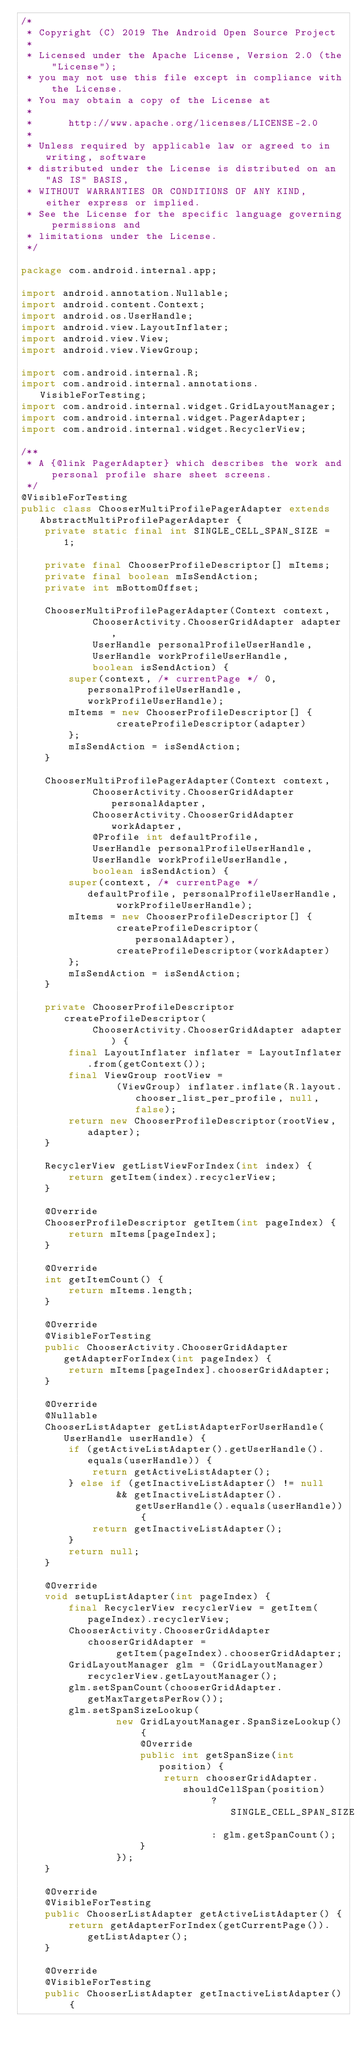Convert code to text. <code><loc_0><loc_0><loc_500><loc_500><_Java_>/*
 * Copyright (C) 2019 The Android Open Source Project
 *
 * Licensed under the Apache License, Version 2.0 (the "License");
 * you may not use this file except in compliance with the License.
 * You may obtain a copy of the License at
 *
 *      http://www.apache.org/licenses/LICENSE-2.0
 *
 * Unless required by applicable law or agreed to in writing, software
 * distributed under the License is distributed on an "AS IS" BASIS,
 * WITHOUT WARRANTIES OR CONDITIONS OF ANY KIND, either express or implied.
 * See the License for the specific language governing permissions and
 * limitations under the License.
 */

package com.android.internal.app;

import android.annotation.Nullable;
import android.content.Context;
import android.os.UserHandle;
import android.view.LayoutInflater;
import android.view.View;
import android.view.ViewGroup;

import com.android.internal.R;
import com.android.internal.annotations.VisibleForTesting;
import com.android.internal.widget.GridLayoutManager;
import com.android.internal.widget.PagerAdapter;
import com.android.internal.widget.RecyclerView;

/**
 * A {@link PagerAdapter} which describes the work and personal profile share sheet screens.
 */
@VisibleForTesting
public class ChooserMultiProfilePagerAdapter extends AbstractMultiProfilePagerAdapter {
    private static final int SINGLE_CELL_SPAN_SIZE = 1;

    private final ChooserProfileDescriptor[] mItems;
    private final boolean mIsSendAction;
    private int mBottomOffset;

    ChooserMultiProfilePagerAdapter(Context context,
            ChooserActivity.ChooserGridAdapter adapter,
            UserHandle personalProfileUserHandle,
            UserHandle workProfileUserHandle,
            boolean isSendAction) {
        super(context, /* currentPage */ 0, personalProfileUserHandle, workProfileUserHandle);
        mItems = new ChooserProfileDescriptor[] {
                createProfileDescriptor(adapter)
        };
        mIsSendAction = isSendAction;
    }

    ChooserMultiProfilePagerAdapter(Context context,
            ChooserActivity.ChooserGridAdapter personalAdapter,
            ChooserActivity.ChooserGridAdapter workAdapter,
            @Profile int defaultProfile,
            UserHandle personalProfileUserHandle,
            UserHandle workProfileUserHandle,
            boolean isSendAction) {
        super(context, /* currentPage */ defaultProfile, personalProfileUserHandle,
                workProfileUserHandle);
        mItems = new ChooserProfileDescriptor[] {
                createProfileDescriptor(personalAdapter),
                createProfileDescriptor(workAdapter)
        };
        mIsSendAction = isSendAction;
    }

    private ChooserProfileDescriptor createProfileDescriptor(
            ChooserActivity.ChooserGridAdapter adapter) {
        final LayoutInflater inflater = LayoutInflater.from(getContext());
        final ViewGroup rootView =
                (ViewGroup) inflater.inflate(R.layout.chooser_list_per_profile, null, false);
        return new ChooserProfileDescriptor(rootView, adapter);
    }

    RecyclerView getListViewForIndex(int index) {
        return getItem(index).recyclerView;
    }

    @Override
    ChooserProfileDescriptor getItem(int pageIndex) {
        return mItems[pageIndex];
    }

    @Override
    int getItemCount() {
        return mItems.length;
    }

    @Override
    @VisibleForTesting
    public ChooserActivity.ChooserGridAdapter getAdapterForIndex(int pageIndex) {
        return mItems[pageIndex].chooserGridAdapter;
    }

    @Override
    @Nullable
    ChooserListAdapter getListAdapterForUserHandle(UserHandle userHandle) {
        if (getActiveListAdapter().getUserHandle().equals(userHandle)) {
            return getActiveListAdapter();
        } else if (getInactiveListAdapter() != null
                && getInactiveListAdapter().getUserHandle().equals(userHandle)) {
            return getInactiveListAdapter();
        }
        return null;
    }

    @Override
    void setupListAdapter(int pageIndex) {
        final RecyclerView recyclerView = getItem(pageIndex).recyclerView;
        ChooserActivity.ChooserGridAdapter chooserGridAdapter =
                getItem(pageIndex).chooserGridAdapter;
        GridLayoutManager glm = (GridLayoutManager) recyclerView.getLayoutManager();
        glm.setSpanCount(chooserGridAdapter.getMaxTargetsPerRow());
        glm.setSpanSizeLookup(
                new GridLayoutManager.SpanSizeLookup() {
                    @Override
                    public int getSpanSize(int position) {
                        return chooserGridAdapter.shouldCellSpan(position)
                                ? SINGLE_CELL_SPAN_SIZE
                                : glm.getSpanCount();
                    }
                });
    }

    @Override
    @VisibleForTesting
    public ChooserListAdapter getActiveListAdapter() {
        return getAdapterForIndex(getCurrentPage()).getListAdapter();
    }

    @Override
    @VisibleForTesting
    public ChooserListAdapter getInactiveListAdapter() {</code> 